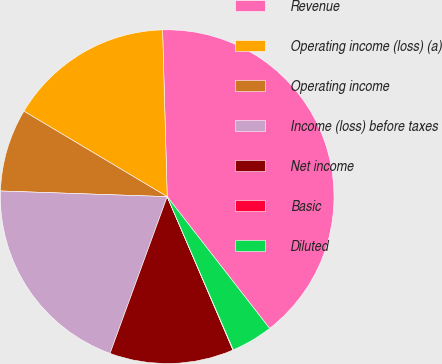Convert chart to OTSL. <chart><loc_0><loc_0><loc_500><loc_500><pie_chart><fcel>Revenue<fcel>Operating income (loss) (a)<fcel>Operating income<fcel>Income (loss) before taxes<fcel>Net income<fcel>Basic<fcel>Diluted<nl><fcel>39.93%<fcel>16.0%<fcel>8.02%<fcel>19.98%<fcel>12.01%<fcel>0.04%<fcel>4.03%<nl></chart> 